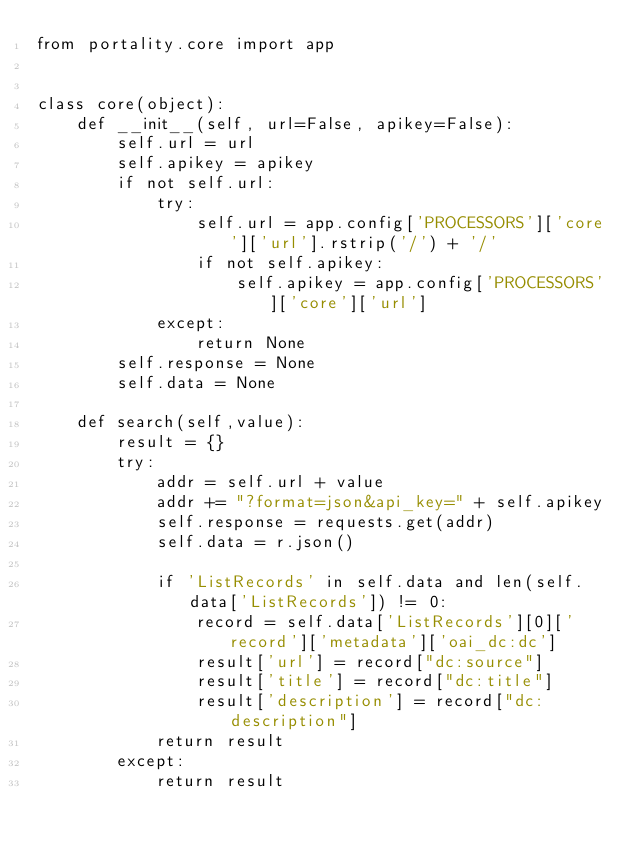<code> <loc_0><loc_0><loc_500><loc_500><_Python_>from portality.core import app

    
class core(object):
    def __init__(self, url=False, apikey=False):
        self.url = url
        self.apikey = apikey
        if not self.url:
            try:
                self.url = app.config['PROCESSORS']['core']['url'].rstrip('/') + '/'
                if not self.apikey:
                    self.apikey = app.config['PROCESSORS']['core']['url']
            except:
                return None
        self.response = None
        self.data = None

    def search(self,value):
        result = {}
        try:
            addr = self.url + value
            addr += "?format=json&api_key=" + self.apikey
            self.response = requests.get(addr)
            self.data = r.json()
    
            if 'ListRecords' in self.data and len(self.data['ListRecords']) != 0:
                record = self.data['ListRecords'][0]['record']['metadata']['oai_dc:dc']
                result['url'] = record["dc:source"]
                result['title'] = record["dc:title"]
                result['description'] = record["dc:description"]
            return result
        except:
            return result



</code> 